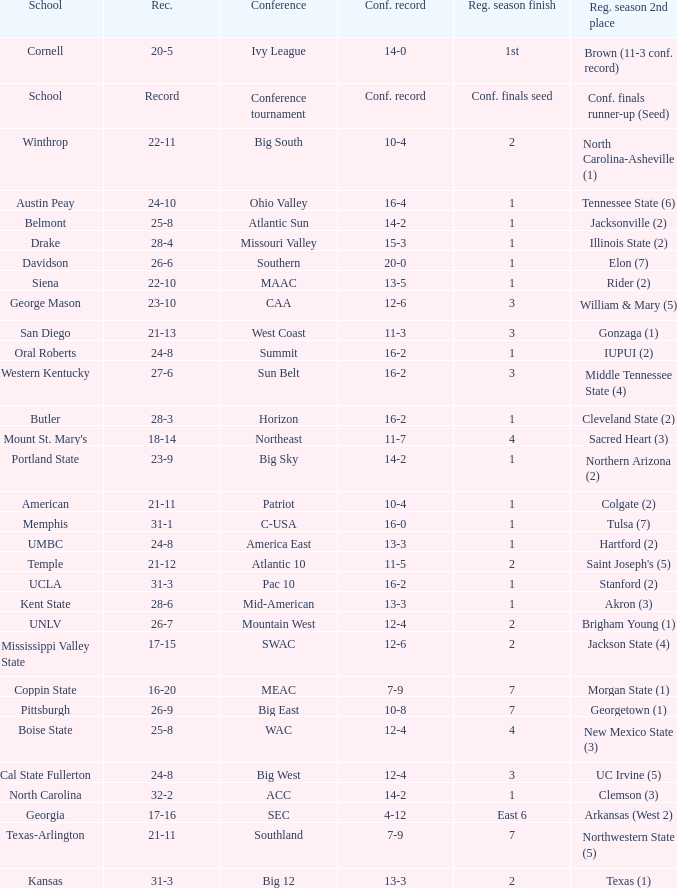Which qualifying schools were in the Patriot conference? American. 